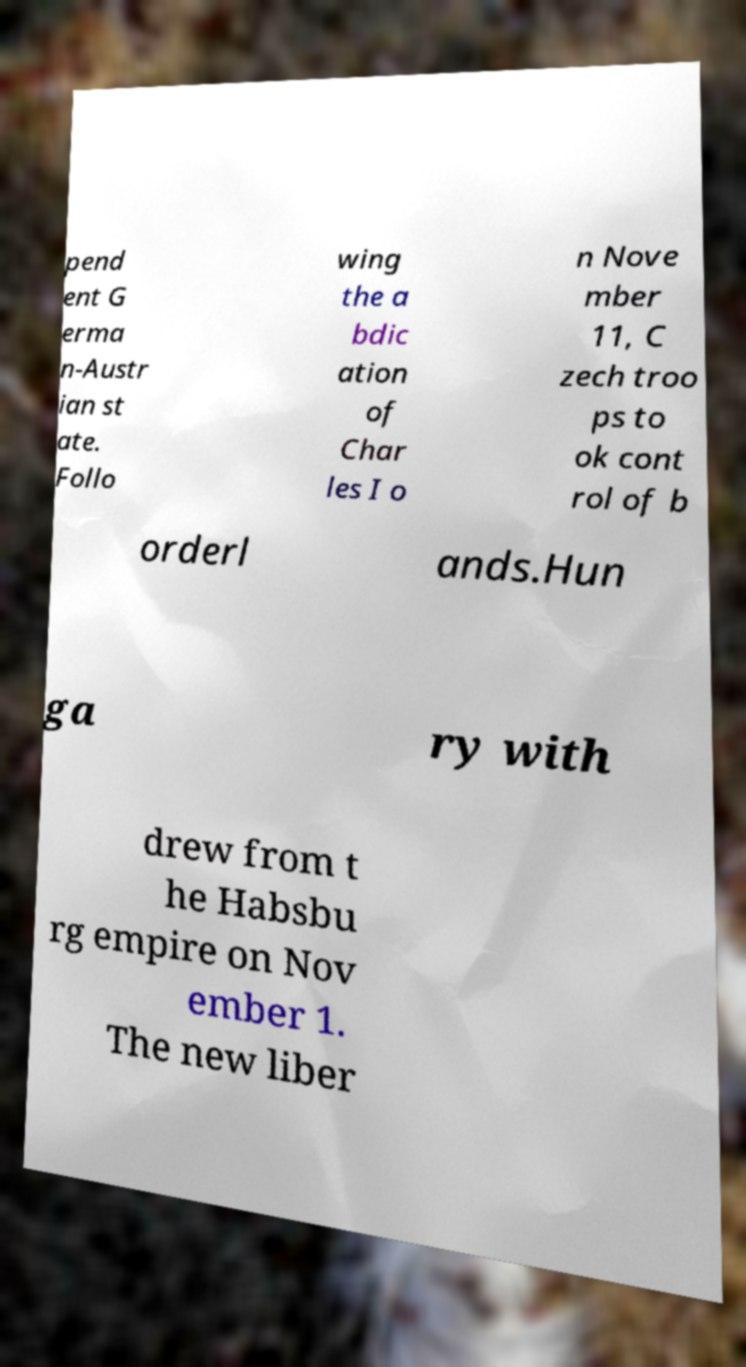I need the written content from this picture converted into text. Can you do that? pend ent G erma n-Austr ian st ate. Follo wing the a bdic ation of Char les I o n Nove mber 11, C zech troo ps to ok cont rol of b orderl ands.Hun ga ry with drew from t he Habsbu rg empire on Nov ember 1. The new liber 